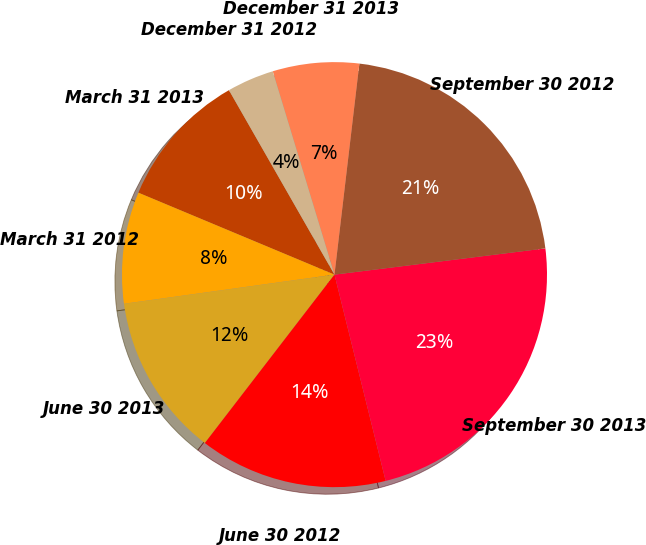Convert chart to OTSL. <chart><loc_0><loc_0><loc_500><loc_500><pie_chart><fcel>March 31 2013<fcel>March 31 2012<fcel>June 30 2013<fcel>June 30 2012<fcel>September 30 2013<fcel>September 30 2012<fcel>December 31 2013<fcel>December 31 2012<nl><fcel>10.43%<fcel>8.49%<fcel>12.37%<fcel>14.31%<fcel>23.1%<fcel>21.16%<fcel>6.56%<fcel>3.58%<nl></chart> 